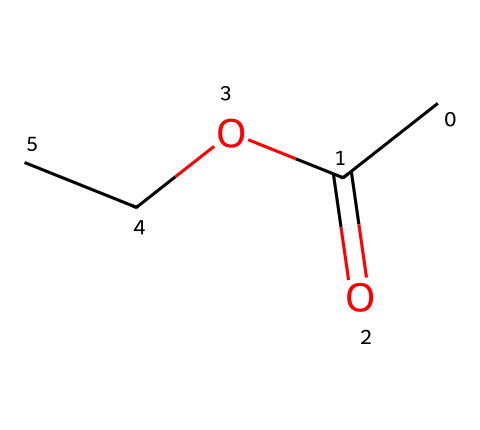What is the name of this chemical? The SMILES notation "CC(=O)OCC" indicates that this molecule is composed of an acetate group (CC(=O)O) bonded to an ethyl group (CC). Together, this structure represents ethyl acetate.
Answer: ethyl acetate How many carbon atoms are in ethyl acetate? In the structure represented by the SMILES, there are two carbon atoms from the ethyl group (CC) and one from the carbonyl (C=O) of the acetate group, totaling three carbon atoms.
Answer: three What functional group is present in ethyl acetate? The presence of the carbonyl group (C=O) combined with the alkoxide (OCC) indicates that the functional group present is an ester.
Answer: ester What is the total number of oxygen atoms in ethyl acetate? The SMILES representation includes one carbonyl oxygen (C=O) and one ether oxygen (OCC), giving a total of two oxygen atoms.
Answer: two How many double bonds are there in ethyl acetate? The structure shows a single double bond in the carbonyl group (C=O), while all other bonds are single, leading to one double bond in the entire molecule.
Answer: one What kind of oligomer chain is present in the ester composition of ethyl acetate? The structure shows a simple linear arrangement with no complex oligomer chain, just a straightforward combination of carbon and oxygen atoms, indicative of simple esters like ethyl acetate.
Answer: simple linear 